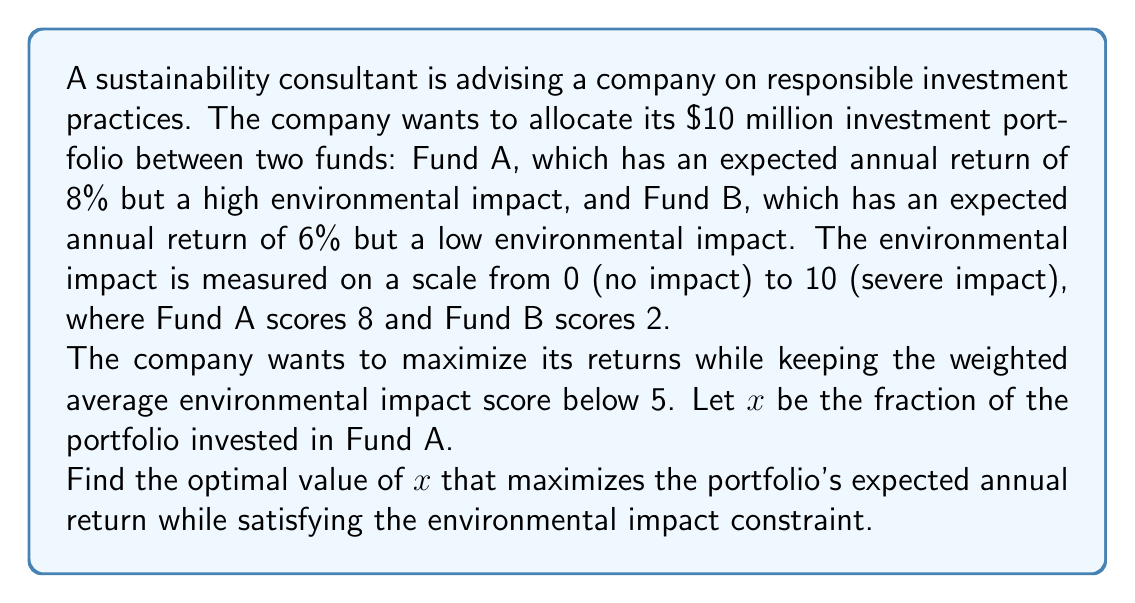What is the answer to this math problem? Let's approach this step-by-step:

1) First, let's express the portfolio's expected return as a function of $x$:
   $R(x) = 0.08x + 0.06(1-x) = 0.08x + 0.06 - 0.06x = 0.02x + 0.06$

2) Now, let's express the weighted average environmental impact score:
   $E(x) = 8x + 2(1-x) = 8x + 2 - 2x = 6x + 2$

3) We want to keep $E(x)$ below 5:
   $6x + 2 \leq 5$
   $6x \leq 3$
   $x \leq 0.5$

4) To maximize returns, we want to invest as much as possible in Fund A while satisfying this constraint. Therefore, the optimal value of $x$ is 0.5.

5) Let's verify:
   At $x = 0.5$:
   $R(0.5) = 0.02(0.5) + 0.06 = 0.07$ or 7% return
   $E(0.5) = 6(0.5) + 2 = 5$, which meets our environmental impact constraint

6) Any value of $x > 0.5$ would violate the environmental impact constraint, while any value of $x < 0.5$ would result in a lower return.
Answer: $x = 0.5$ 